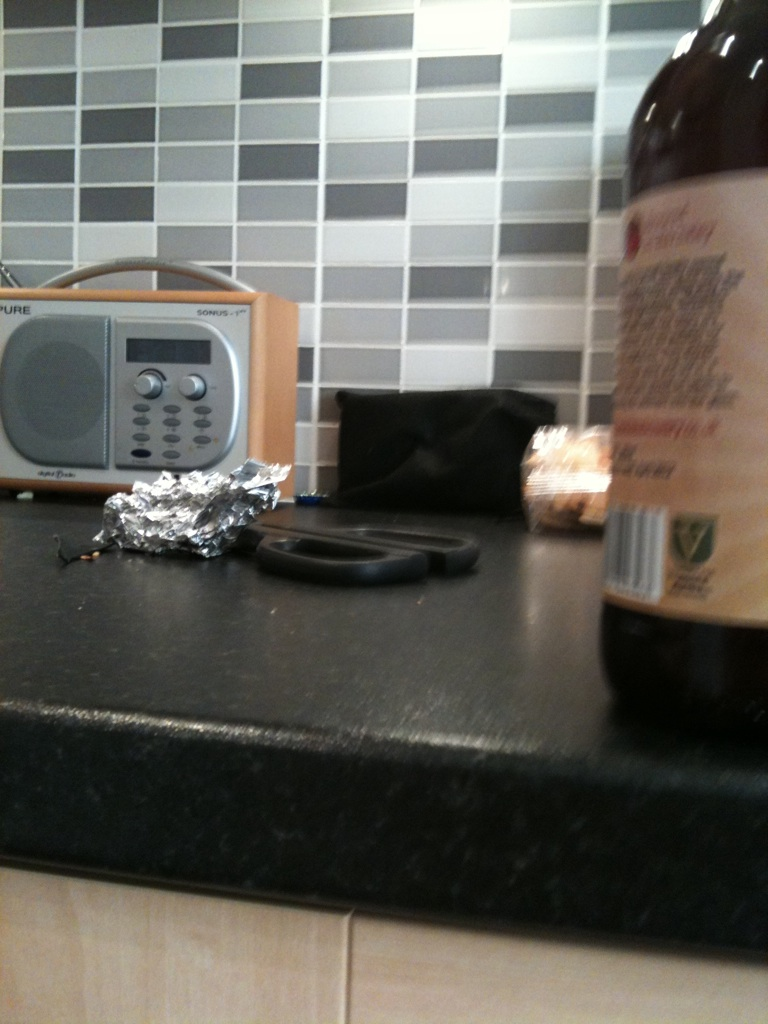Please read this label on the bottle. I'm sorry, but the text on the label is blurry and not readable from the image provided. To assist further, please take a closer, clearer photo of the label, or provide details about what specific information you are looking for (ingredients, manufacturer, etc.). 